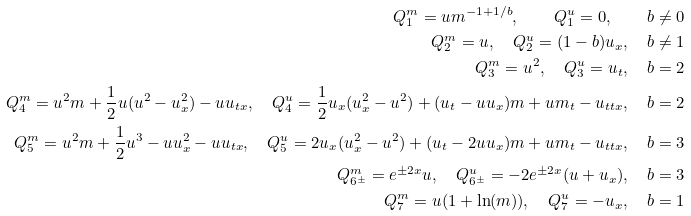<formula> <loc_0><loc_0><loc_500><loc_500>Q ^ { m } _ { 1 } = u m ^ { - 1 + 1 / b } , \quad Q ^ { u } _ { 1 } = 0 , \quad b \neq 0 \\ Q ^ { m } _ { 2 } = u , \quad Q ^ { u } _ { 2 } = ( 1 - b ) u _ { x } , \quad b \neq 1 \\ Q ^ { m } _ { 3 } = u ^ { 2 } , \quad Q ^ { u } _ { 3 } = u _ { t } , \quad b = 2 \\ Q ^ { m } _ { 4 } = u ^ { 2 } m + \frac { 1 } { 2 } u ( u ^ { 2 } - u _ { x } ^ { 2 } ) - u u _ { t x } , \quad Q ^ { u } _ { 4 } = \frac { 1 } { 2 } u _ { x } ( u _ { x } ^ { 2 } - u ^ { 2 } ) + ( u _ { t } - u u _ { x } ) m + u m _ { t } - u _ { t t x } , \quad b = 2 \\ Q ^ { m } _ { 5 } = u ^ { 2 } m + \frac { 1 } { 2 } u ^ { 3 } - u u _ { x } ^ { 2 } - u u _ { t x } , \quad Q ^ { u } _ { 5 } = 2 u _ { x } ( u _ { x } ^ { 2 } - u ^ { 2 } ) + ( u _ { t } - 2 u u _ { x } ) m + u m _ { t } - u _ { t t x } , \quad b = 3 \\ Q ^ { m } _ { 6 ^ { \pm } } = e ^ { \pm 2 x } u , \quad Q ^ { u } _ { 6 ^ { \pm } } = - 2 e ^ { \pm 2 x } ( u + u _ { x } ) , \quad b = 3 \\ Q ^ { m } _ { 7 } = u ( 1 + \ln ( m ) ) , \quad Q ^ { u } _ { 7 } = - u _ { x } , \quad b = 1</formula> 